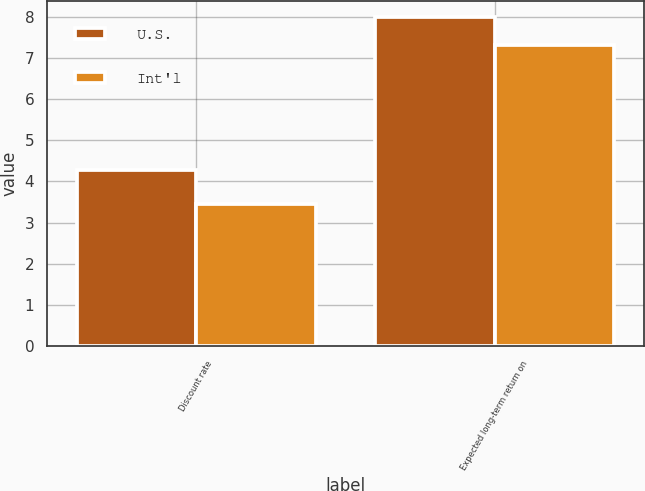<chart> <loc_0><loc_0><loc_500><loc_500><stacked_bar_chart><ecel><fcel>Discount rate<fcel>Expected long-term return on<nl><fcel>U.S.<fcel>4.27<fcel>8<nl><fcel>Int'l<fcel>3.44<fcel>7.31<nl></chart> 